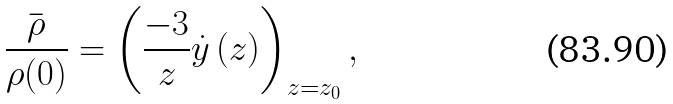<formula> <loc_0><loc_0><loc_500><loc_500>\frac { \overset { \_ } { \rho } } { \rho ( 0 ) } = \left ( \frac { - 3 } { z } \dot { y } \left ( z \right ) \right ) _ { z = z _ { 0 } } ,</formula> 